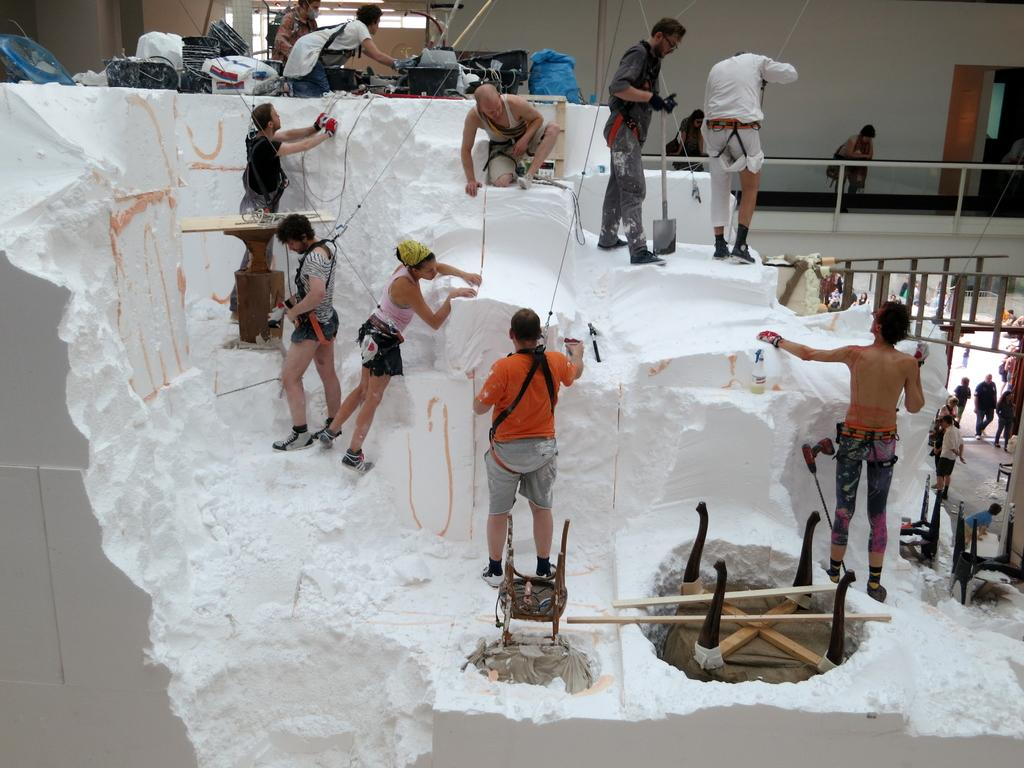How many people are in the image? There are many men and women in the image. What are the people doing in the image? The people are working on a white cement-like substance. What objects can be seen in the image besides the people? There are bags and a table in the image. What protective gear is the man wearing? The man is wearing gloves. What type of footwear is the man wearing? The man is wearing shoes. What type of leather item is being discussed by the people in the image? There is no leather item being discussed in the image; the people are working on a white cement-like substance. What is the mysterious thing that appears in the image? There is no mysterious thing present in the image; the objects and activities are clearly described in the provided facts. 